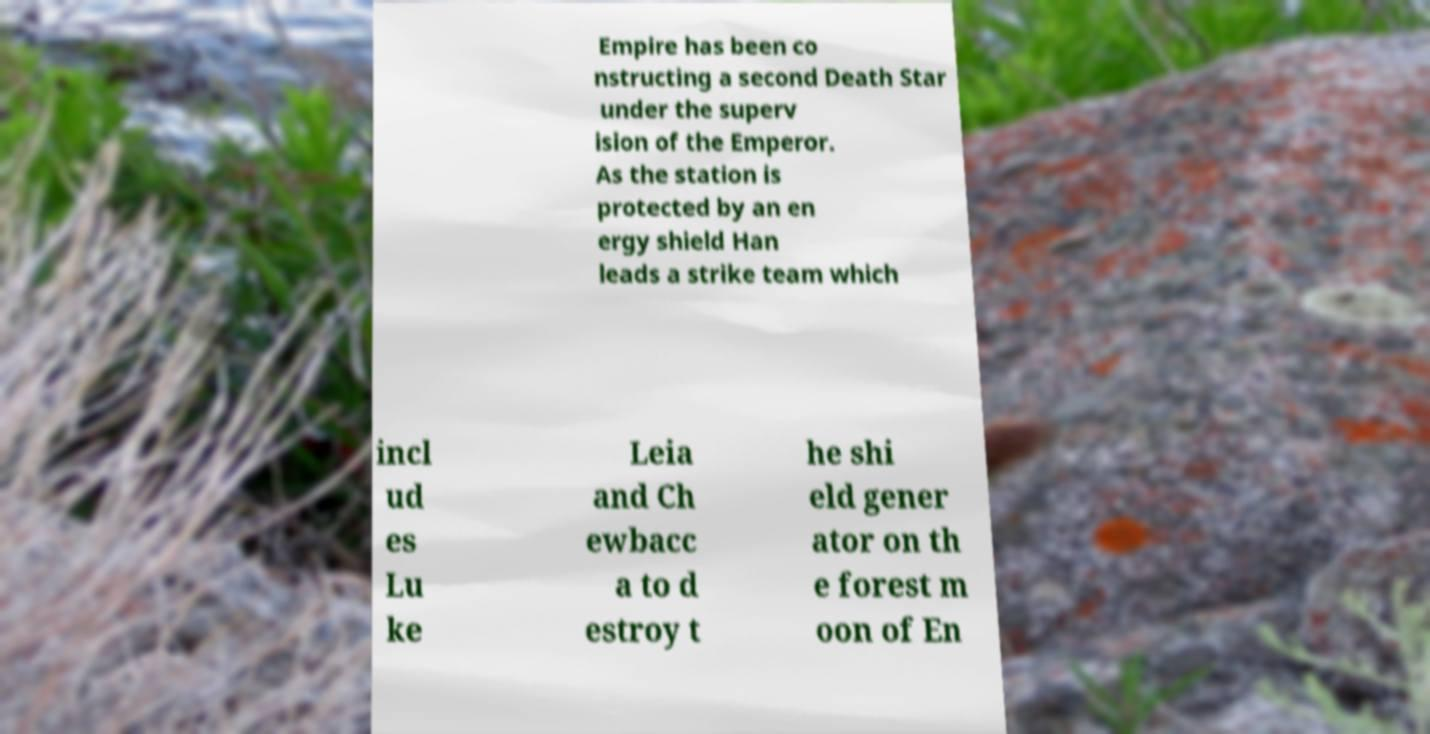There's text embedded in this image that I need extracted. Can you transcribe it verbatim? Empire has been co nstructing a second Death Star under the superv ision of the Emperor. As the station is protected by an en ergy shield Han leads a strike team which incl ud es Lu ke Leia and Ch ewbacc a to d estroy t he shi eld gener ator on th e forest m oon of En 